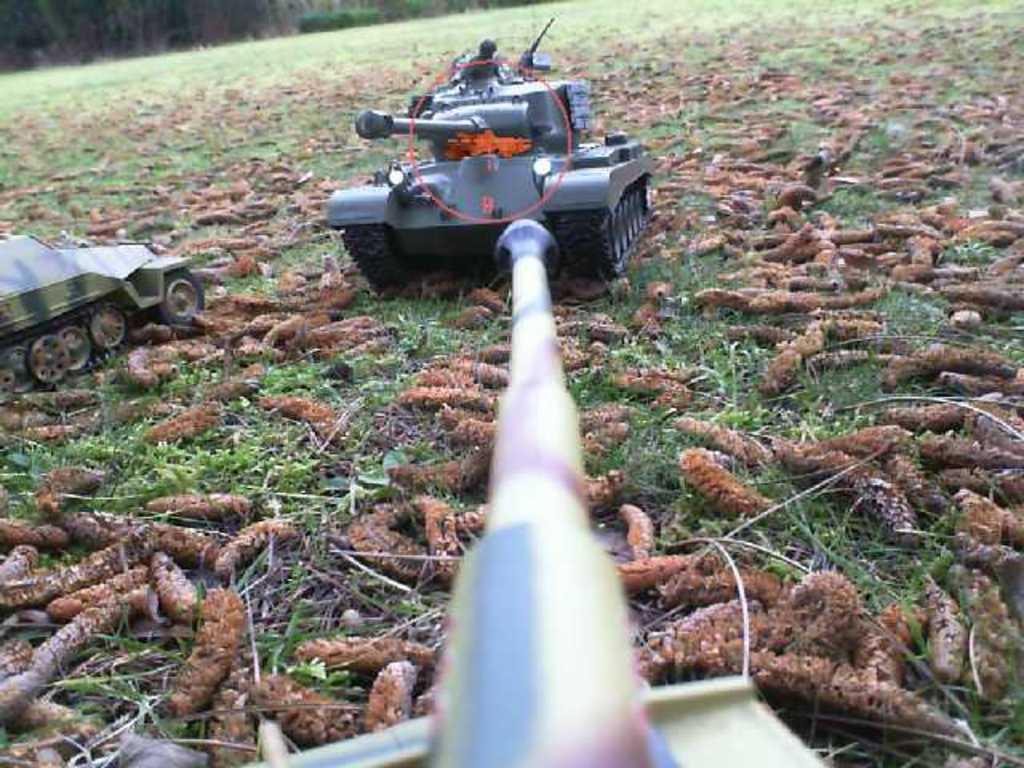How would you summarize this image in a sentence or two? We can see vehicles,worms and grass. In the background we can see plants. 